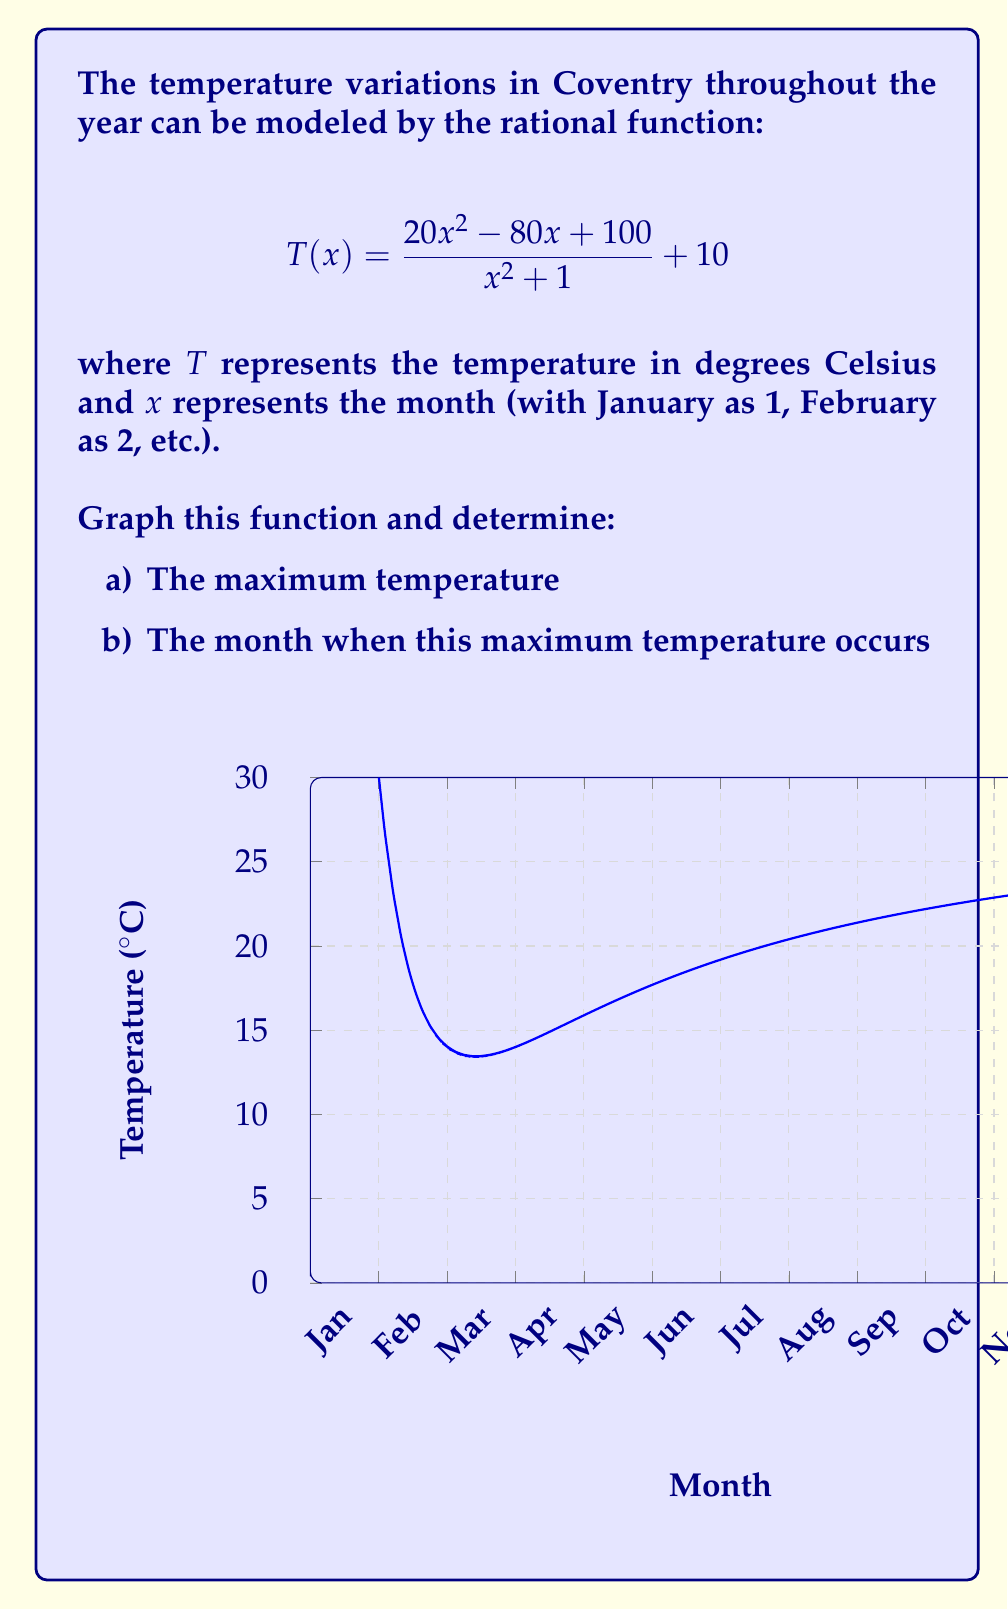Help me with this question. Let's approach this step-by-step:

1) First, we need to graph the function. The graph is provided in the question.

2) To find the maximum temperature and when it occurs, we need to find the vertex of the parabola-like curve.

3) For rational functions of this form, the maximum or minimum typically occurs when $x = -b/(2a)$, where $a$ and $b$ are the coefficients of $x^2$ and $x$ in the numerator.

4) In this case, $a = 20$ and $b = -80$. So:

   $$x = -\frac{-80}{2(20)} = \frac{80}{40} = 2$$

5) This means the maximum temperature occurs when $x = 2$, which corresponds to February.

6) To find the maximum temperature, we substitute $x = 2$ into the original function:

   $$T(2) = \frac{20(2)^2 - 80(2) + 100}{2^2 + 1} + 10$$
   
   $$= \frac{80 - 160 + 100}{5} + 10 = \frac{20}{5} + 10 = 4 + 10 = 14$$

Therefore, the maximum temperature is 14°C and occurs in February.
Answer: a) 14°C
b) February (x = 2) 